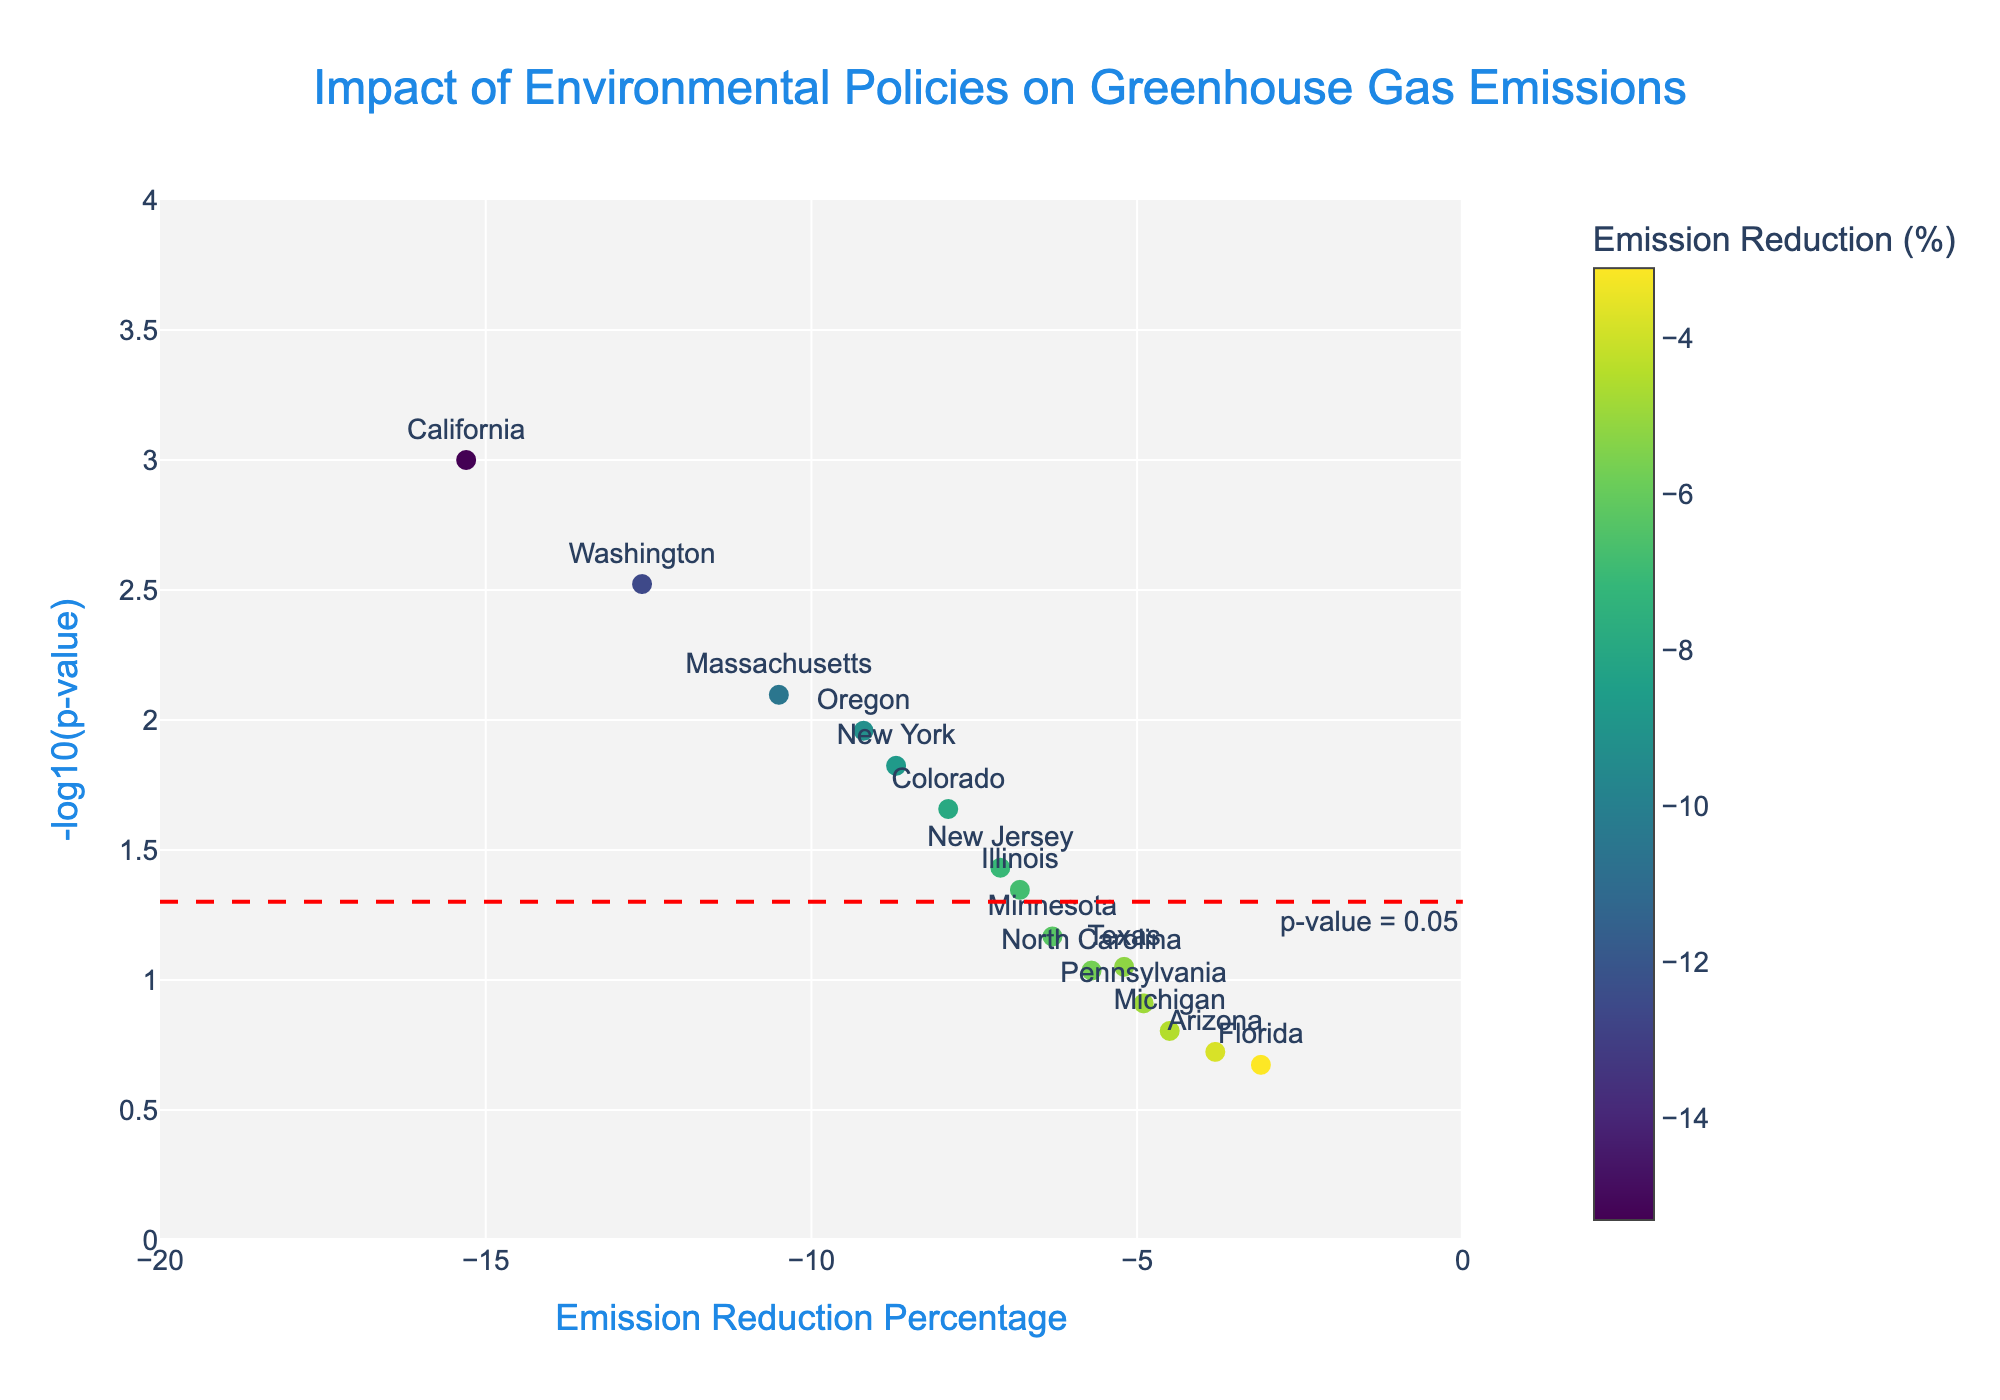What is the title of the figure? The title is prominently displayed at the top of the plot, usually in a larger font.
Answer: Impact of Environmental Policies on Greenhouse Gas Emissions Which state implemented the Cap-and-Trade Program? Each data point is labeled with the state's name. The one labeled "California" represents the Cap-and-Trade Program.
Answer: California What does the x-axis represent? The x-axis title states what it represents.
Answer: Emission Reduction Percentage What does the y-axis represent? The y-axis title states what it represents.
Answer: -log10(p-value) Which state achieved the greatest emission reduction? The point farthest to the left on the x-axis represents the greatest emission reduction.
Answer: California How many states have statistically significant p-values (p < 0.05)? Points above a certain y-axis value (determined by the red line labeled "p-value = 0.05") have a statistically significant p-value. Counting the points above this line gives the answer.
Answer: 8 What emission reduction percentage corresponds to Illinois' Future Energy Jobs Act? Find the data point labeled "Illinois" and look at its position on the x-axis.
Answer: -6.8% Which state has the lowest -log10(p-value) among those with less than 5% emission reduction? Identify points with an emission reduction percentage less than -5%, then find the one with the lowest y-axis value among them.
Answer: Florida Compare the effectiveness of the Cap-and-Trade Program and the Clean Energy Transformation Act. Which one had a higher -log10(p-value)? Locate the points for California (Cap-and-Trade) and Washington (Clean Energy Transformation Act) and compare their y-axis values.
Answer: California Is there a state with a high -log10(p-value) but low emission reduction? If yes, name it. Look for points high on the y-axis but closer to 0 on the x-axis.
Answer: New Jersey 